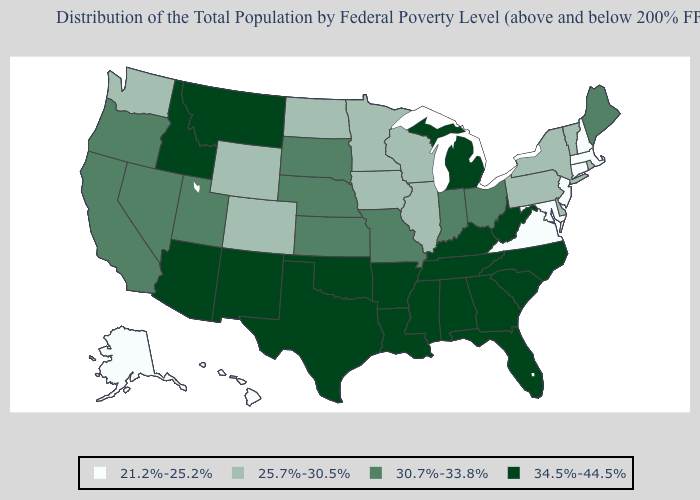Does the map have missing data?
Write a very short answer. No. What is the lowest value in the South?
Answer briefly. 21.2%-25.2%. What is the value of Idaho?
Keep it brief. 34.5%-44.5%. Name the states that have a value in the range 34.5%-44.5%?
Give a very brief answer. Alabama, Arizona, Arkansas, Florida, Georgia, Idaho, Kentucky, Louisiana, Michigan, Mississippi, Montana, New Mexico, North Carolina, Oklahoma, South Carolina, Tennessee, Texas, West Virginia. Among the states that border Virginia , which have the highest value?
Concise answer only. Kentucky, North Carolina, Tennessee, West Virginia. Does Maryland have the highest value in the USA?
Short answer required. No. What is the highest value in the USA?
Concise answer only. 34.5%-44.5%. Name the states that have a value in the range 21.2%-25.2%?
Write a very short answer. Alaska, Connecticut, Hawaii, Maryland, Massachusetts, New Hampshire, New Jersey, Virginia. Which states have the lowest value in the MidWest?
Keep it brief. Illinois, Iowa, Minnesota, North Dakota, Wisconsin. Name the states that have a value in the range 34.5%-44.5%?
Answer briefly. Alabama, Arizona, Arkansas, Florida, Georgia, Idaho, Kentucky, Louisiana, Michigan, Mississippi, Montana, New Mexico, North Carolina, Oklahoma, South Carolina, Tennessee, Texas, West Virginia. What is the value of Delaware?
Write a very short answer. 25.7%-30.5%. Does Virginia have the lowest value in the USA?
Short answer required. Yes. Name the states that have a value in the range 21.2%-25.2%?
Answer briefly. Alaska, Connecticut, Hawaii, Maryland, Massachusetts, New Hampshire, New Jersey, Virginia. How many symbols are there in the legend?
Keep it brief. 4. 